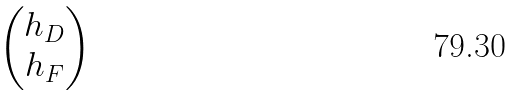<formula> <loc_0><loc_0><loc_500><loc_500>\begin{pmatrix} h _ { D } \\ h _ { F } \end{pmatrix}</formula> 